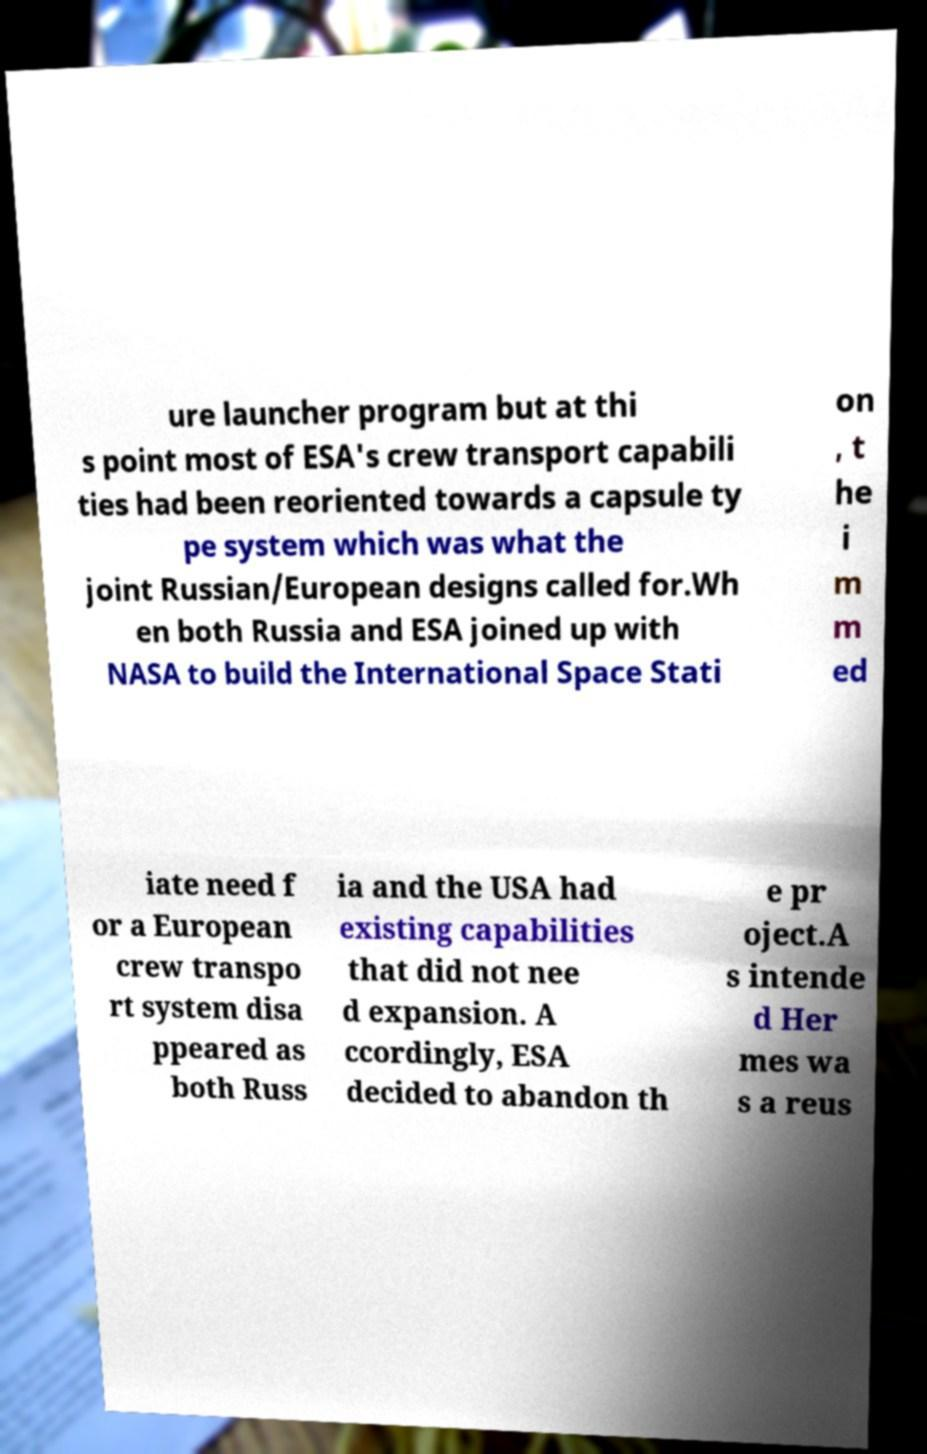For documentation purposes, I need the text within this image transcribed. Could you provide that? ure launcher program but at thi s point most of ESA's crew transport capabili ties had been reoriented towards a capsule ty pe system which was what the joint Russian/European designs called for.Wh en both Russia and ESA joined up with NASA to build the International Space Stati on , t he i m m ed iate need f or a European crew transpo rt system disa ppeared as both Russ ia and the USA had existing capabilities that did not nee d expansion. A ccordingly, ESA decided to abandon th e pr oject.A s intende d Her mes wa s a reus 